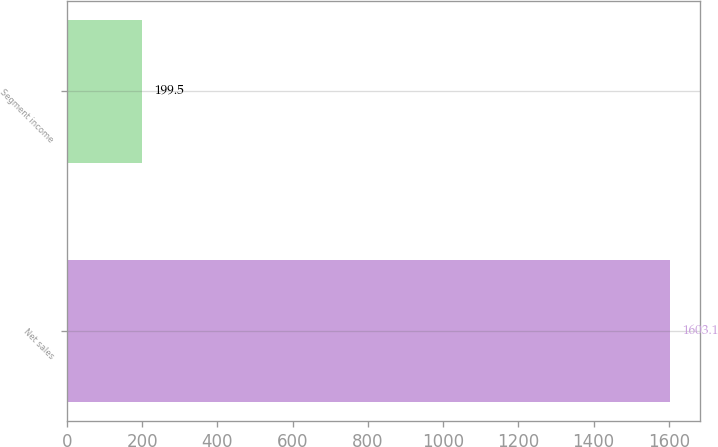<chart> <loc_0><loc_0><loc_500><loc_500><bar_chart><fcel>Net sales<fcel>Segment income<nl><fcel>1603.1<fcel>199.5<nl></chart> 